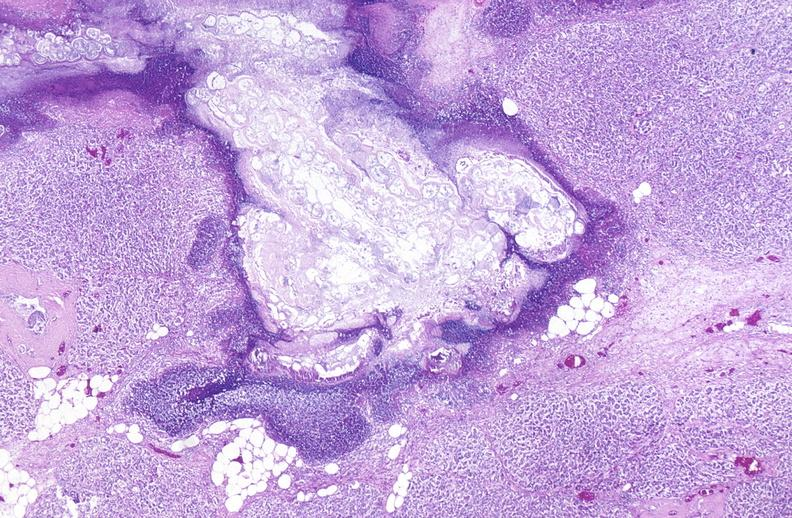where is this?
Answer the question using a single word or phrase. Pancreas 